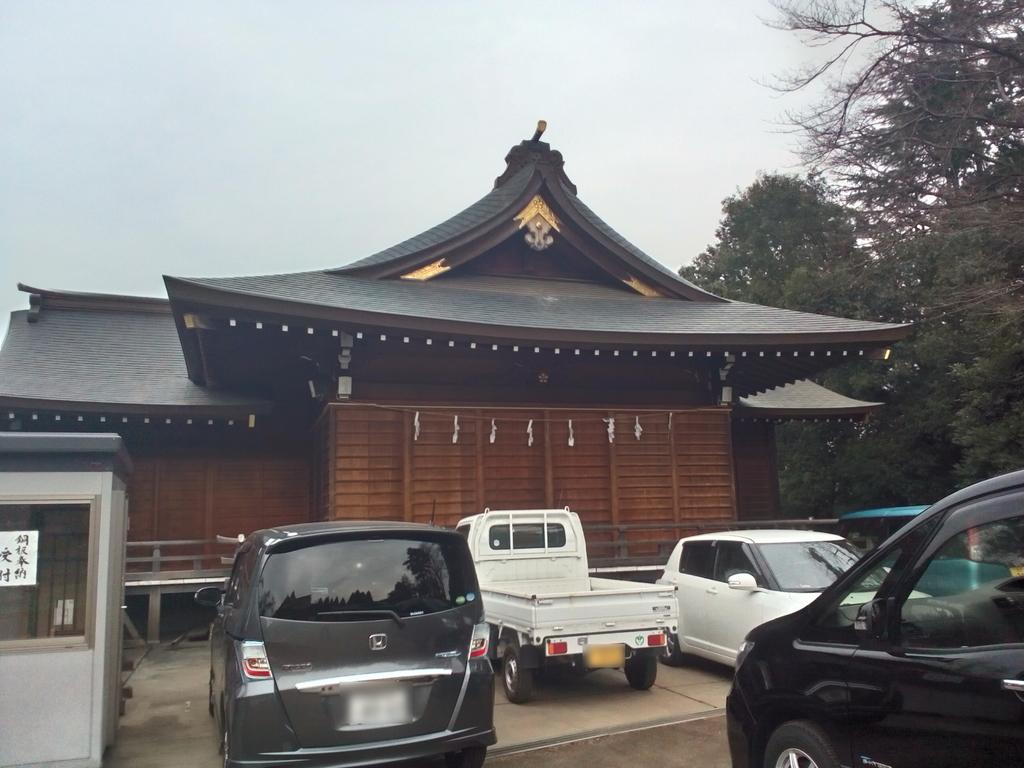What type of structure is visible in the image? There is a building in the image. What vehicles can be seen parked in the image? Cars and a mini truck are parked in the image. Are there any natural elements present in the image? Yes, there are trees in the image. How would you describe the weather based on the image? The sky is cloudy in the image, suggesting a potentially overcast or cloudy day. Where is the desk located in the image? There is no desk present in the image. Is there a crown visible on the building in the image? There is no crown visible on the building or anywhere else in the image. 